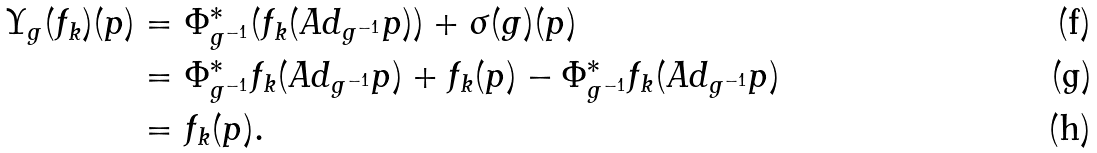<formula> <loc_0><loc_0><loc_500><loc_500>\Upsilon _ { g } ( f _ { k } ) ( p ) & = \Phi ^ { \ast } _ { g ^ { - 1 } } ( f _ { k } ( A d _ { g ^ { - 1 } } p ) ) + \sigma ( g ) ( p ) \\ & = \Phi ^ { \ast } _ { g ^ { - 1 } } f _ { k } ( A d _ { g ^ { - 1 } } p ) + f _ { k } ( p ) - \Phi ^ { \ast } _ { g ^ { - 1 } } f _ { k } ( A d _ { g ^ { - 1 } } p ) \\ & = f _ { k } ( p ) .</formula> 